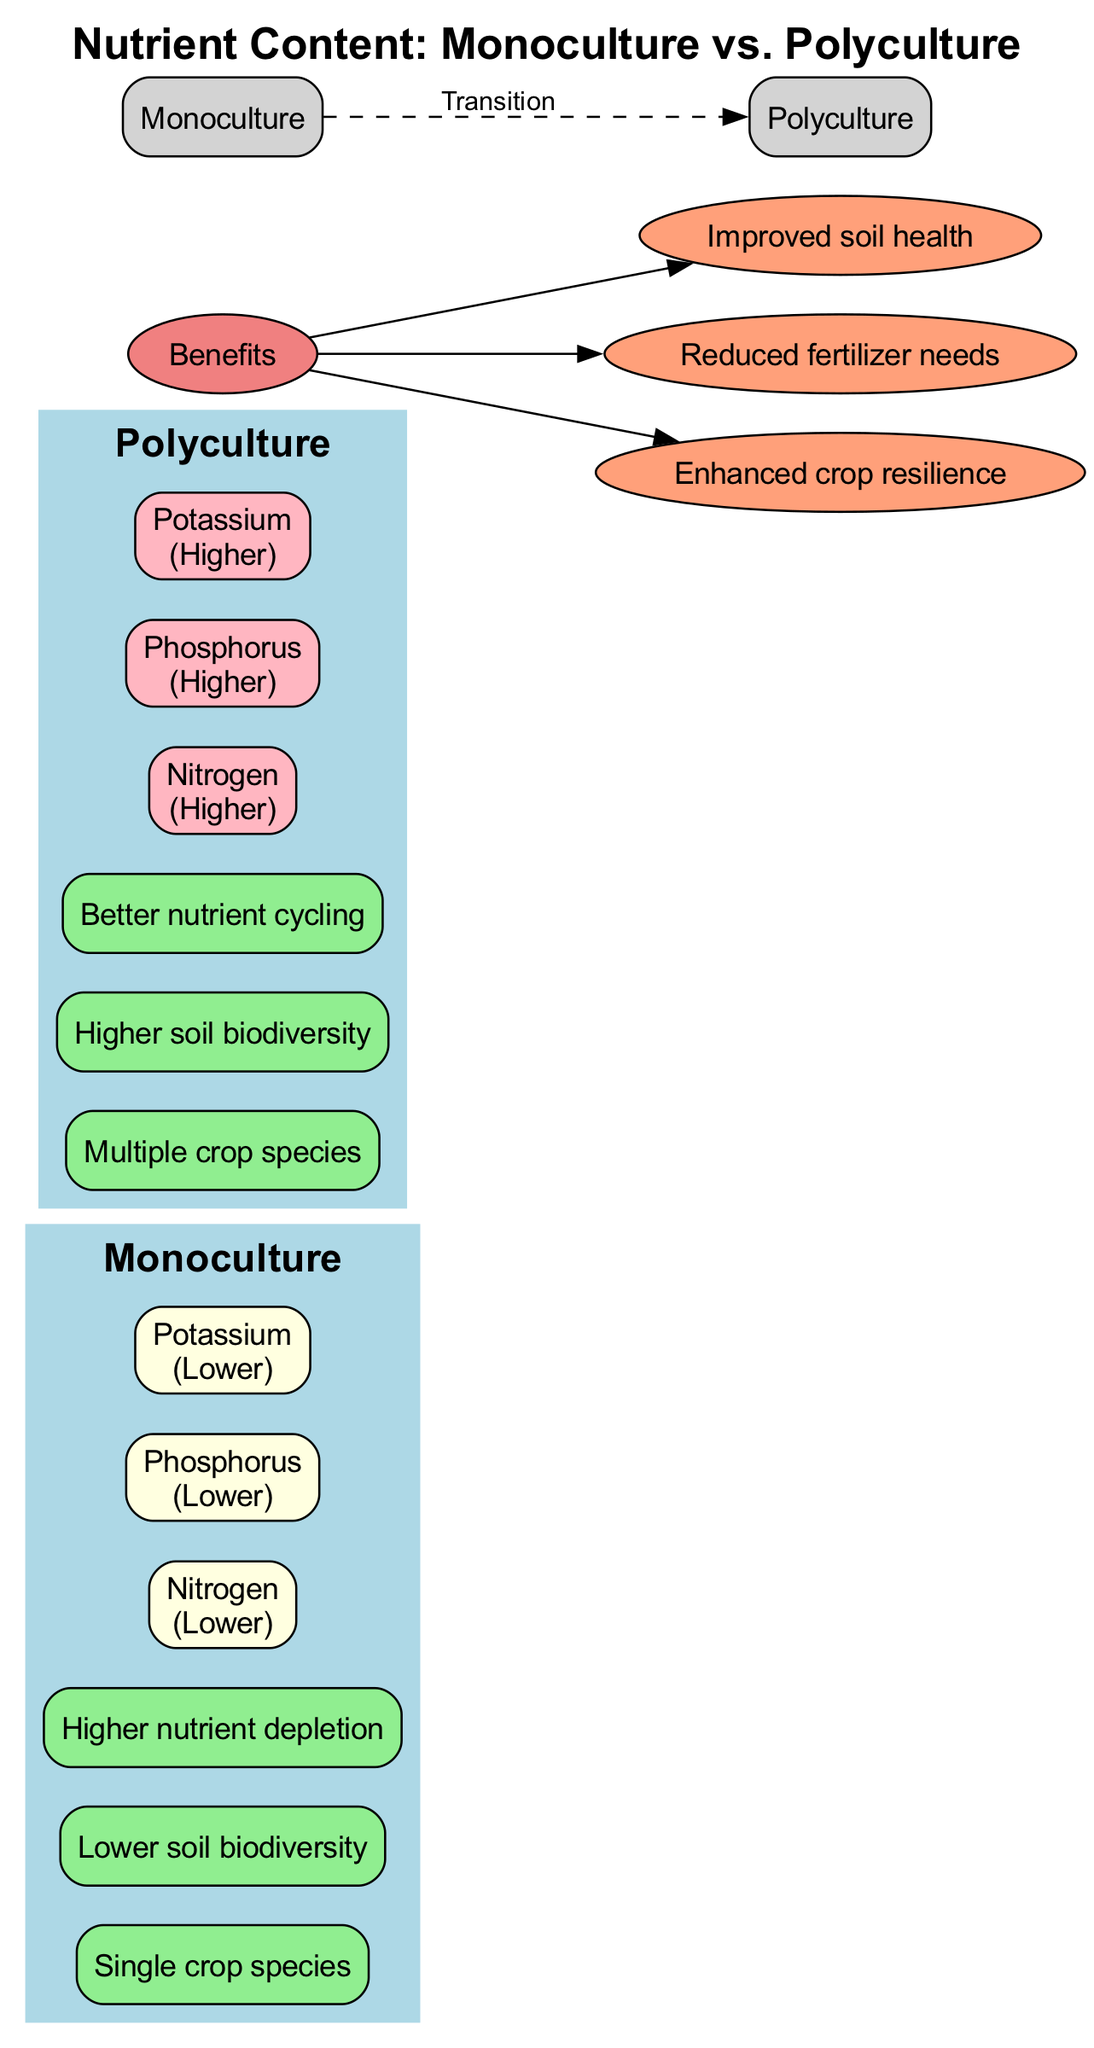What is the nutrient level of Nitrogen in Monoculture? The diagram indicates the nutrient level of Nitrogen under Monoculture farming systems is marked as "Lower.”
Answer: Lower How many crop species are present in a Polyculture system? The characteristics of Polyculture list "Multiple crop species," which clearly indicates there are several crops.
Answer: Multiple What is one benefit listed for both farming systems? The benefits section describes advantages such as "Improved soil health," which applies generally and is a common benefit in sustainable practices.
Answer: Improved soil health Which system has higher Potassium content? By comparing nutrients in both Monoculture and Polyculture within the diagram, Potassium is stated as "Higher" in Polyculture and "Lower" in Monoculture.
Answer: Polyculture What relationship is shown between Monoculture and Polyculture? The diagram illustrates a dashed edge labeled "Transition" that connects Monoculture to Polyculture, indicating a potential movement from one system to the other.
Answer: Transition How many nutrients are listed for each farming system? The nutrient information shows three nutrients: Nitrogen, Phosphorus, and Potassium listed for both systems, indicating they each have the same number of nutrients focused upon.
Answer: Three What color represents the nutrient levels that are 'Lower'? In the diagram, the nutrient levels labeled as 'Lower' are represented by the color "lightyellow" for Monoculture, indicating a specific visual cue for lower nutrient content.
Answer: Lightyellow Which farming system is associated with better nutrient cycling? The characteristics for Polyculture clearly mention "Better nutrient cycling," suggesting this system supports a more effective nutrient cycle compared to Monoculture.
Answer: Polyculture What is one characteristic of Monoculture farming systems? The characteristics description for Monoculture includes "Single crop species," highlighting a key aspect of this farming practice.
Answer: Single crop species 